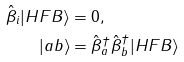Convert formula to latex. <formula><loc_0><loc_0><loc_500><loc_500>\hat { \beta } _ { i } | H F B \rangle & = 0 , \\ | a b \rangle & = \hat { \beta } ^ { \dagger } _ { a } \hat { \beta } ^ { \dagger } _ { b } | H F B \rangle</formula> 